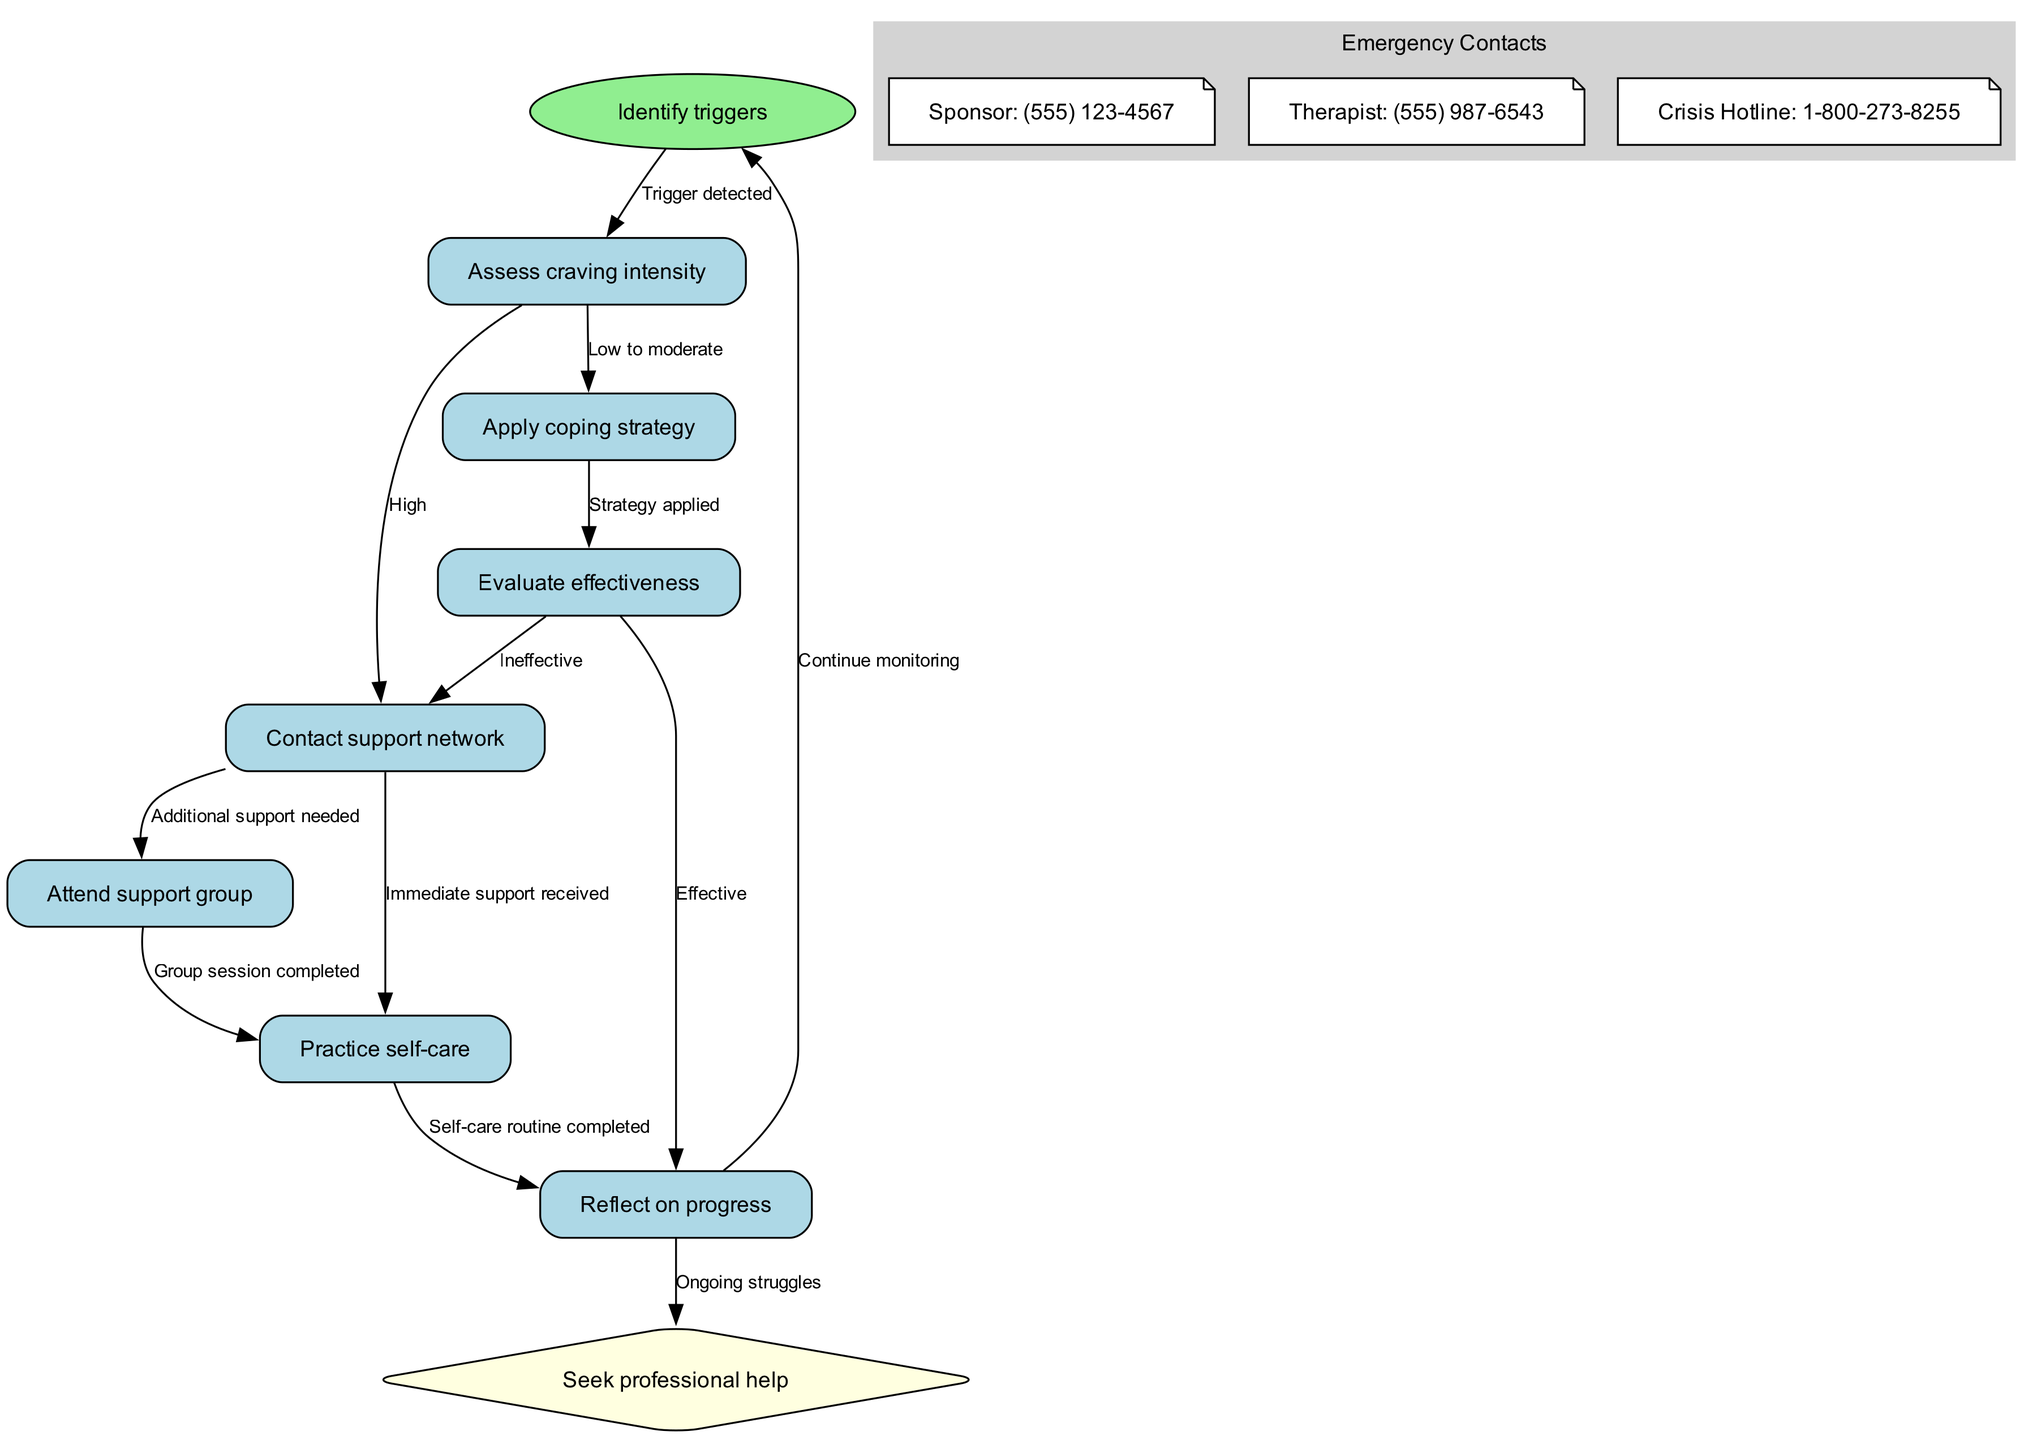What is the first step in the flowchart? The first step is indicated by the starting node labeled "Identify triggers" which is the initial action to take upon detecting a potential relapse trigger.
Answer: Identify triggers How many nodes are present in the diagram? By counting the distinct items listed in the nodes section, there are a total of 9 nodes representing different actions and decisions in the flow of the flowchart.
Answer: 9 What action follows "Assess craving intensity" when it's low to moderate? According to the edge associated with "Assess craving intensity" for low to moderate intensity, the next action taken is to "Apply coping strategy" as the flow indicates to apply a strategy when craving levels are manageable.
Answer: Apply coping strategy What happens if the effectiveness of the coping strategy is evaluated as ineffective? If the coping strategy is deemed ineffective after being applied, the flowchart indicates to "Contact support network" as the next step, which guides users to seek additional support.
Answer: Contact support network Which node leads to the option of seeking professional help? The flowchart specifies that the pathway leading to the option of "Seek professional help" occurs when the person reflects on their progress and is experiencing ongoing struggles, as explained in the connections outlined within the flowchart.
Answer: Reflect on progress What is an action taken after attending a support group? After completing a group session labeled "Attend support group," the next action indicated in the flowchart is to "Practice self-care," implying the necessity to care for oneself post-group activities.
Answer: Practice self-care What type of node is "Seek professional help"? In the flowchart, "Seek professional help" is specifically categorized as a diamond-shaped node, which represents a decision point that can lead to different pathways based on the individual's needs.
Answer: Diamond What indicates a need for additional support in the diagram? The diagram indicates a need for additional support specifically when the "Contact support network" node is followed by the edge labeled "Additional support needed," reflecting that more resources may be necessary.
Answer: Additional support needed How is self-care related to reflecting on progress? The flowchart illustrates a connection that shows after completing a self-care routine, the next step is to "Reflect on progress," establishing a feedback loop where self-care influences ongoing evaluation.
Answer: Reflect on progress 